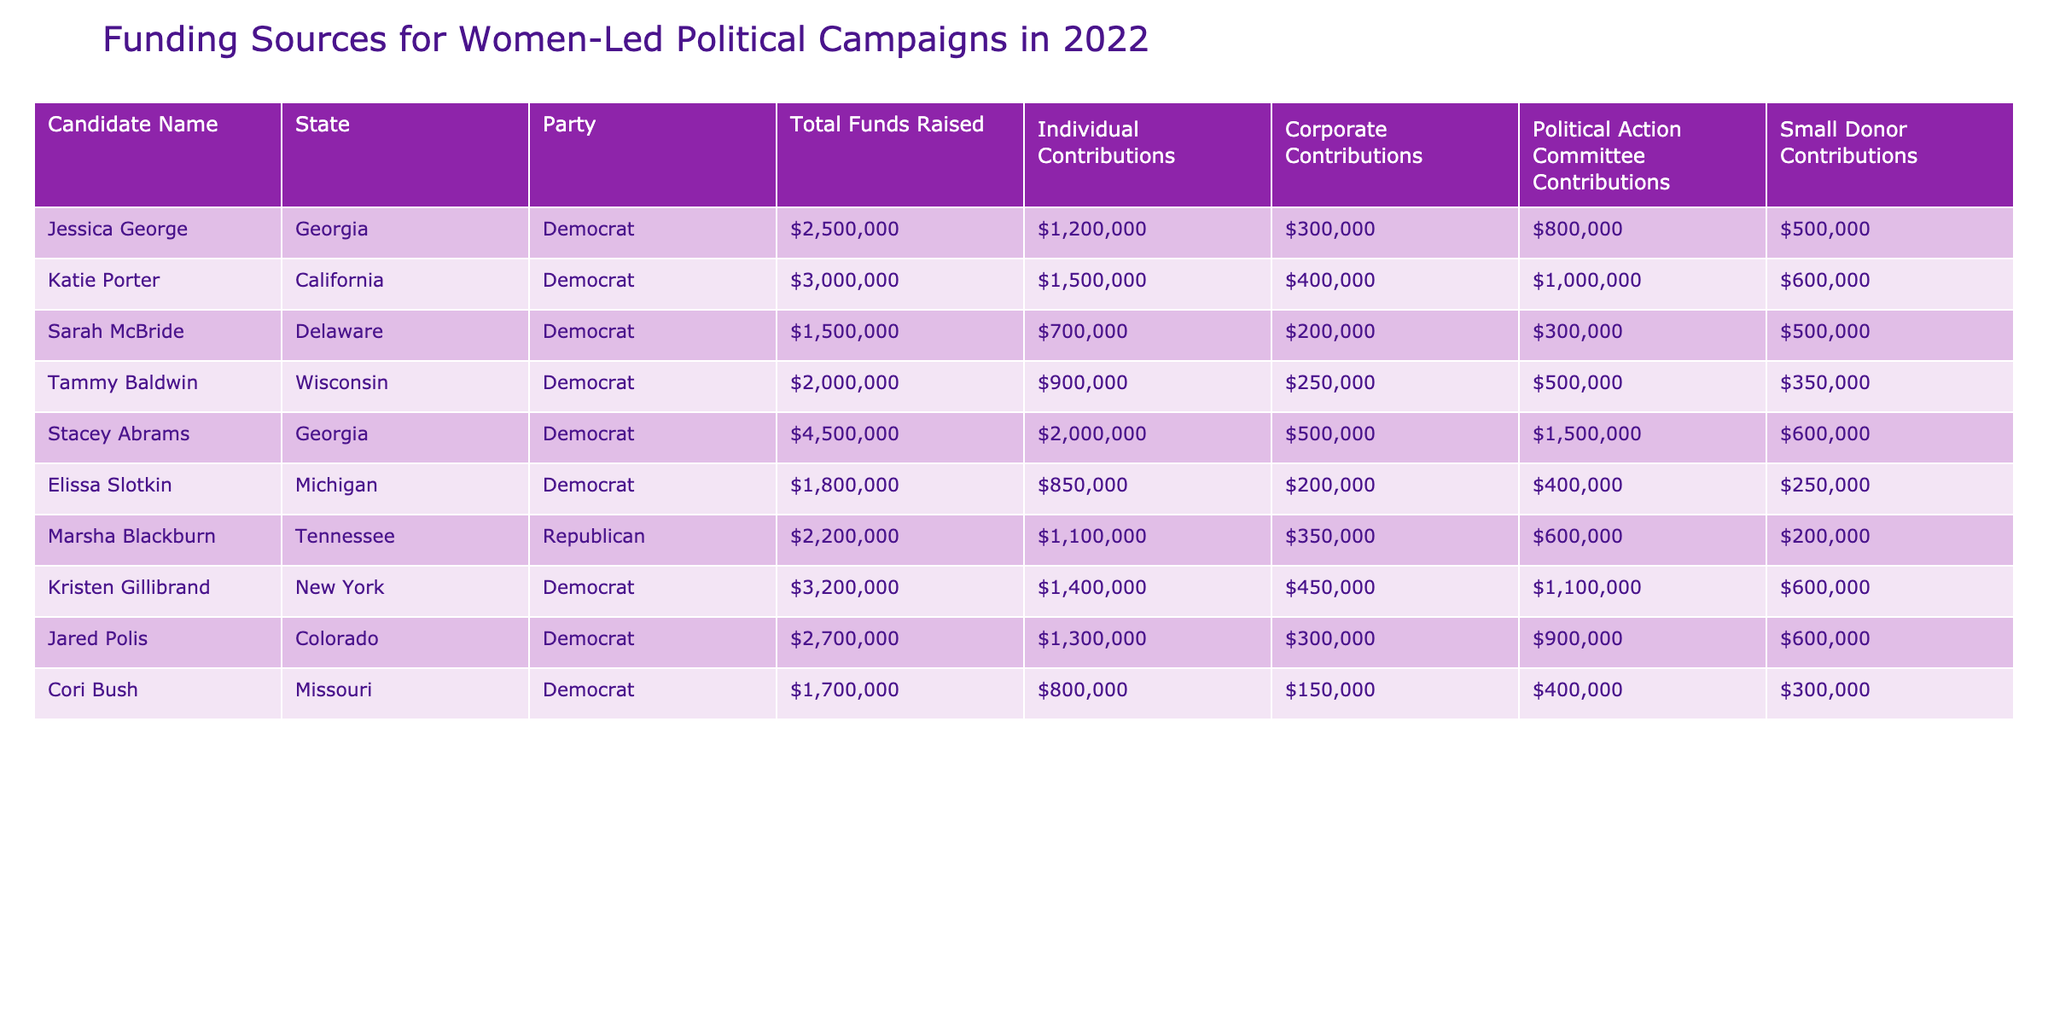What is the total funds raised by Jessica George? Jessica George's row in the table shows that she raised a total of $2,500,000.
Answer: $2,500,000 Which candidate raised the highest total funds in 2022? Looking at the "Total Funds Raised" column, Stacey Abrams has the highest value at $4,500,000.
Answer: Stacey Abrams What is the combined amount of individual contributions for all candidates? To find the total individual contributions, sum the values: 1,200,000 + 1,500,000 + 700,000 + 900,000 + 2,000,000 + 850,000 + 1,100,000 + 1,300,000 + 800,000 = 10,500,000.
Answer: $10,500,000 Did every candidate receive contributions from political action committees? Examining the "Political Action Committee Contributions" column, Cori Bush did not receive any contributions from political action committees (0), indicating that not every candidate received these contributions.
Answer: No What is the average total funds raised by the candidates in Georgia? The candidates in Georgia are Jessica George and Stacey Abrams. Their total funds raised are $2,500,000 and $4,500,000 respectively. Summing these gives $7,000,000; averaging these amounts gives $7,000,000 / 2 = $3,500,000.
Answer: $3,500,000 Is it true that the majority of candidates had more individual contributions than PAC contributions? By comparing each candidate's individual and PAC contributions, we find that for all candidates except for Marsha Blackburn, individual contributions are greater than PAC contributions. Thus, the statement is true as the majority was satisfied.
Answer: Yes What is the total amount raised from small donors across all candidates? Adding up the "Small Donor Contributions": 500,000 + 600,000 + 500,000 + 350,000 + 600,000 + 250,000 + 200,000 + 600,000 + 300,000 gives a total of $4,950,000.
Answer: $4,950,000 Which candidate has the highest corporate contributions and how much did they raise? Upon reviewing the "Corporate Contributions" column, Kristen Gillibrand has the highest amount of corporate contributions, totaling $450,000.
Answer: Kristen Gillibrand, $450,000 How much larger were total funds raised by Stacey Abrams compared to Jessica George? The difference can be calculated by subtracting Jessica George's total funds ($2,500,000) from Stacey Abrams' total funds ($4,500,000), resulting in a $2,000,000 difference.
Answer: $2,000,000 